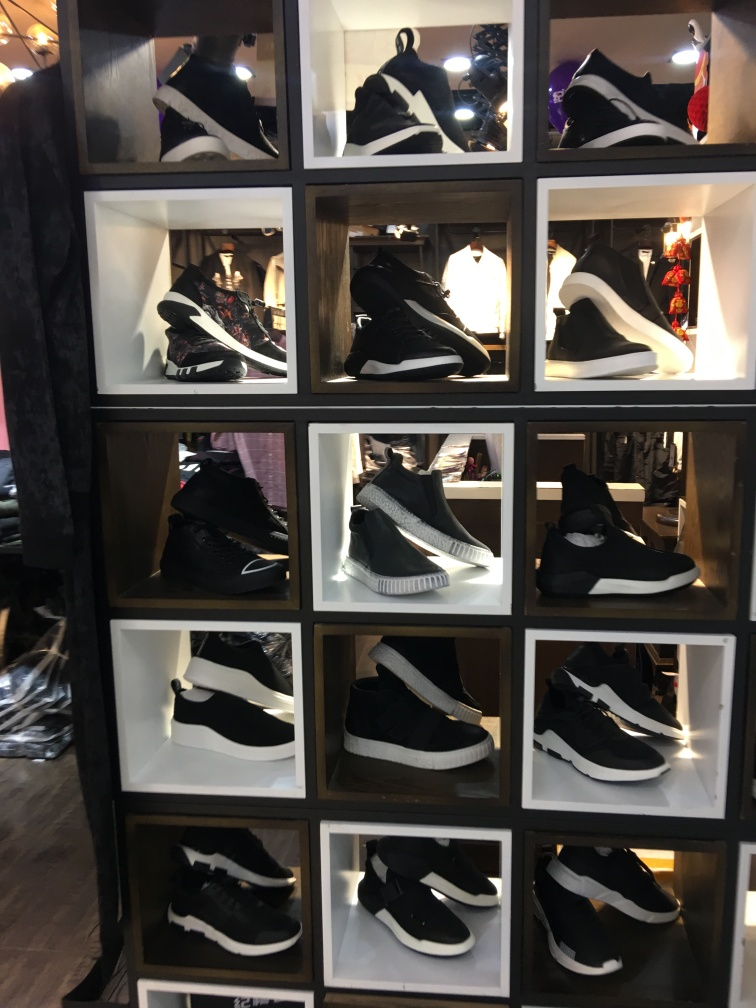Could you describe the style and potential use cases for the sneakers displayed? The sneakers showcased vary in design and style, ranging from high-tops to ones with chunky soles. These sneakers can serve multiple use cases, like casual streetwear due to their sleek black and white color scheme, or possibly as part of a sporty, active attire because of their supportive designs. Some pairs might also be suitable for fashion-forward events, as a few exhibit a contemporary and trendy look. 